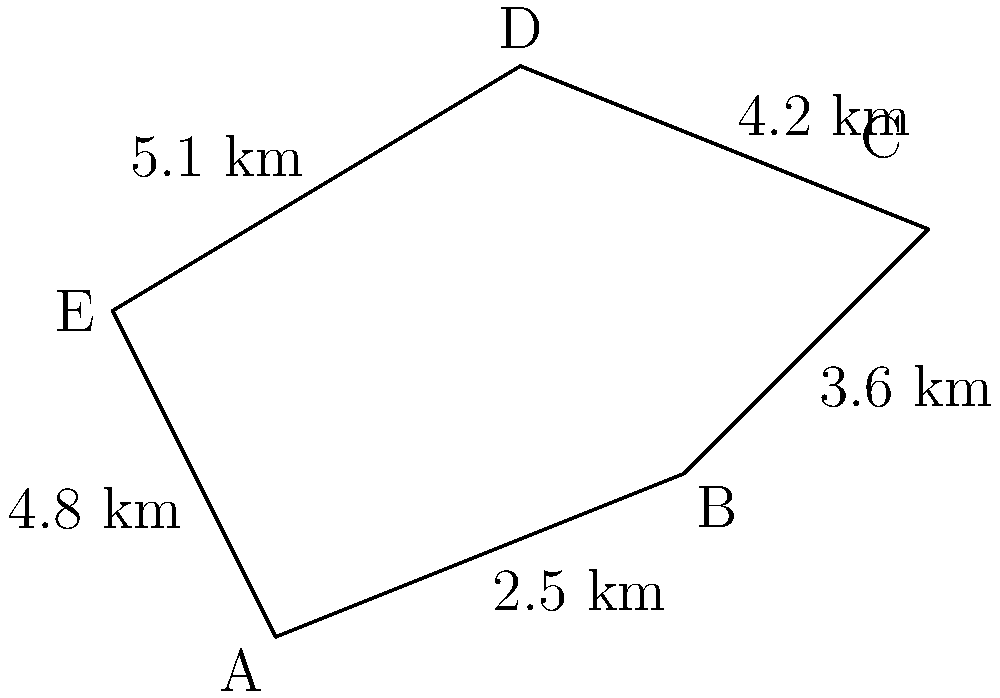As a postman, you've been assigned a new route in the neighborhood. The route is represented by the pentagonal shape ABCDE in the diagram. Given the distances between consecutive points as shown, calculate the total perimeter of your postal route in kilometers. To find the perimeter of the postal route, we need to sum up the distances between all consecutive points in the pentagonal shape ABCDE. Let's break it down step-by-step:

1. Distance AB = 2.5 km
2. Distance BC = 3.6 km
3. Distance CD = 4.2 km
4. Distance DE = 5.1 km
5. Distance EA = 4.8 km

Now, let's add all these distances:

$$\text{Perimeter} = AB + BC + CD + DE + EA$$
$$\text{Perimeter} = 2.5 + 3.6 + 4.2 + 5.1 + 4.8$$
$$\text{Perimeter} = 20.2 \text{ km}$$

Therefore, the total perimeter of your postal route is 20.2 kilometers.
Answer: 20.2 km 